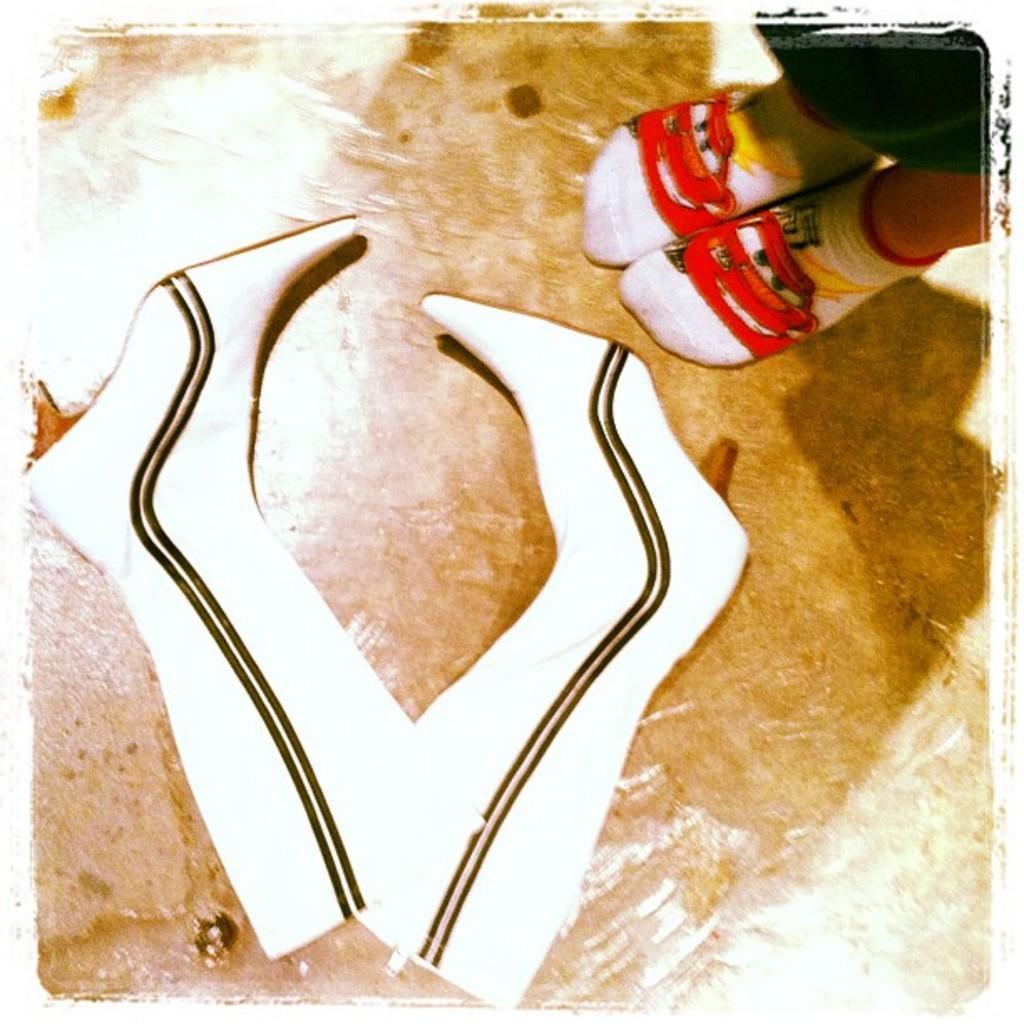Describe this image in one or two sentences. In this image I can see a person's foot. I can see a pair of shoes. 